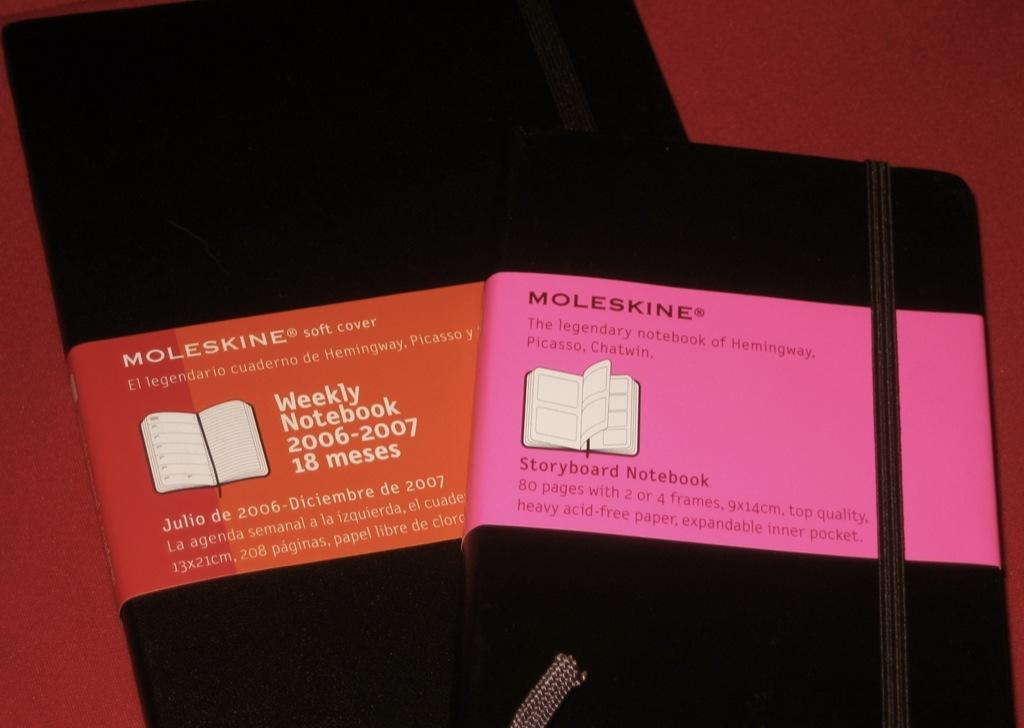<image>
Provide a brief description of the given image. Moleskine brand note pads have pink and red labels. 